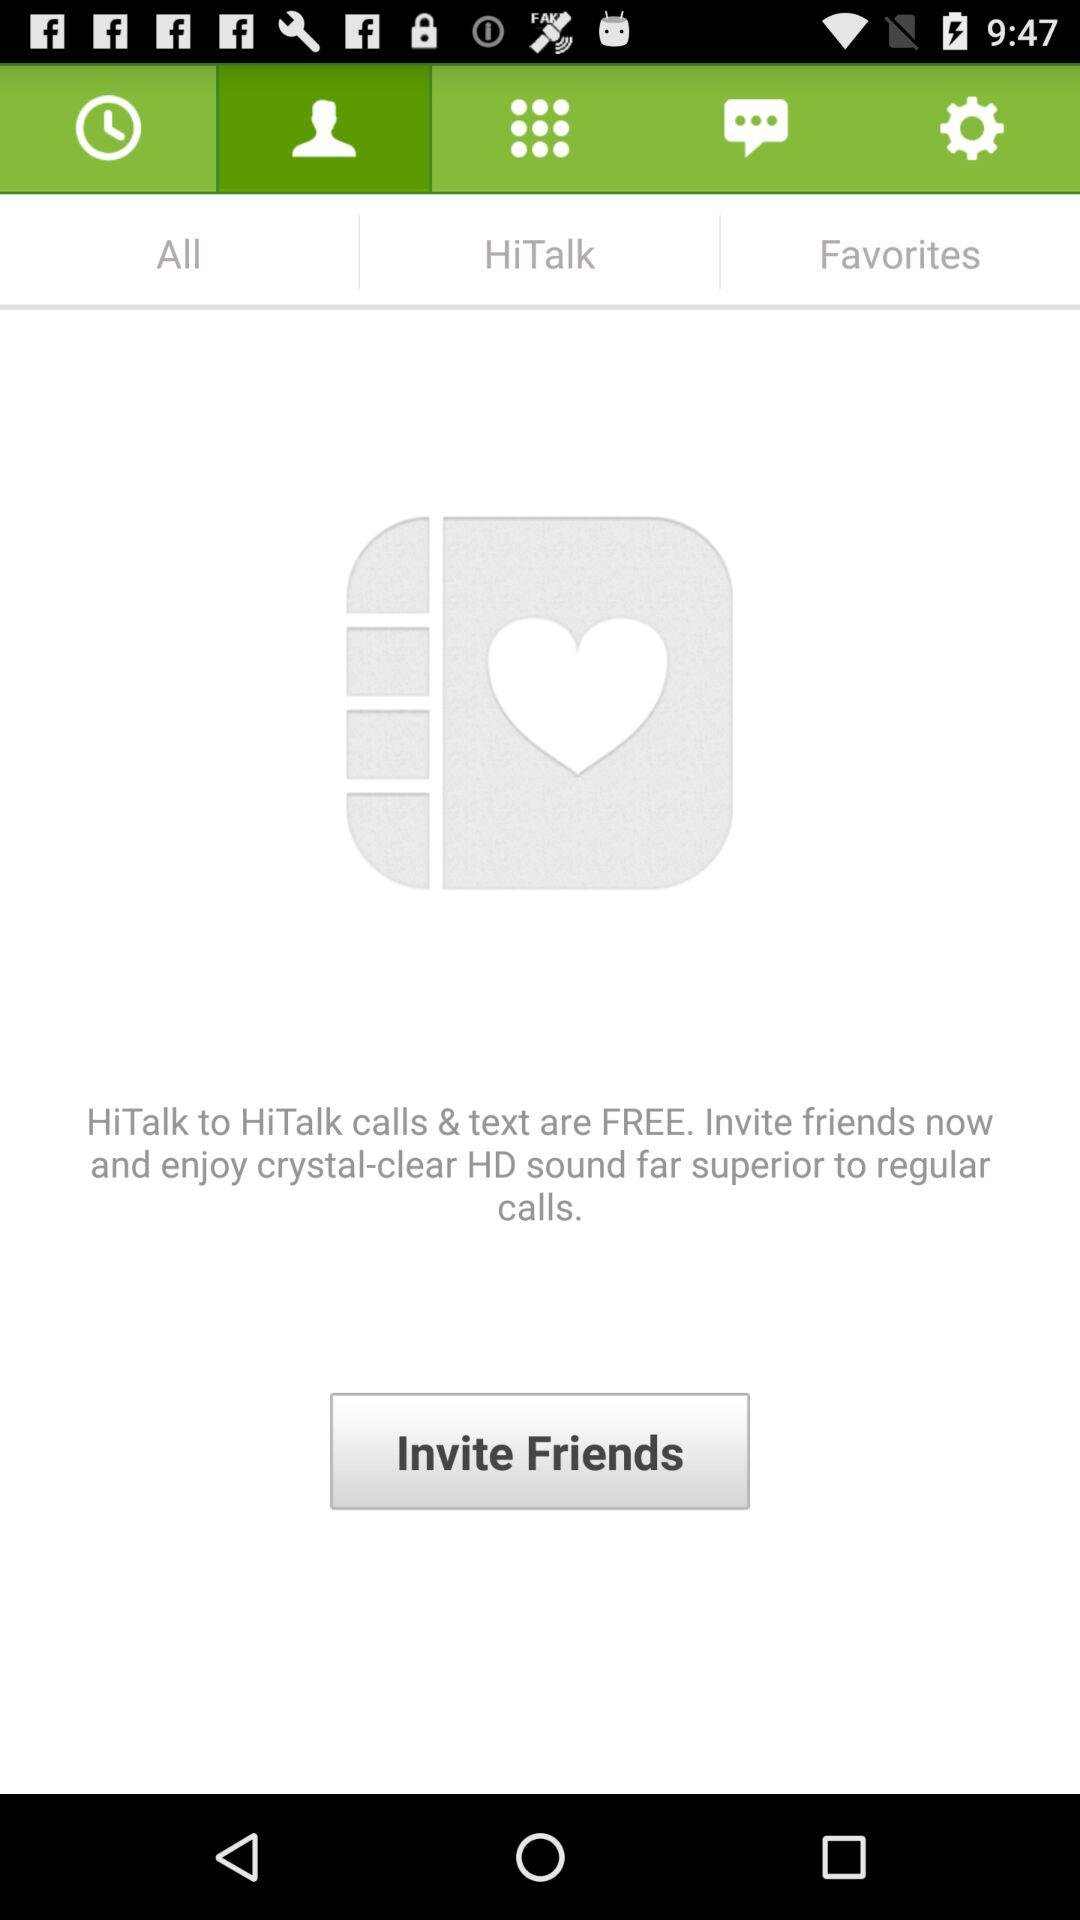Who can we invite to experience "crystal clear HD sound"? You can invite friends to experience "crystal clear HD sound". 